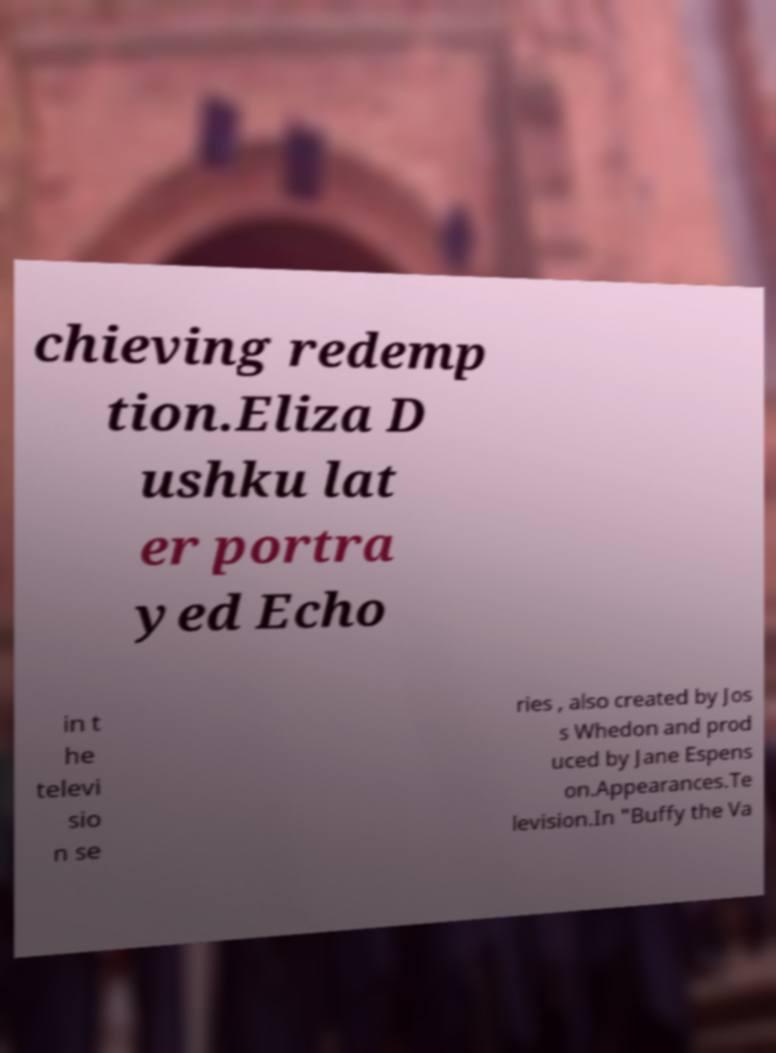There's text embedded in this image that I need extracted. Can you transcribe it verbatim? chieving redemp tion.Eliza D ushku lat er portra yed Echo in t he televi sio n se ries , also created by Jos s Whedon and prod uced by Jane Espens on.Appearances.Te levision.In "Buffy the Va 